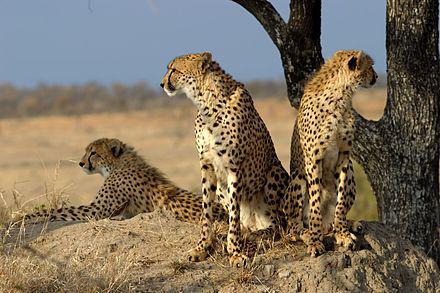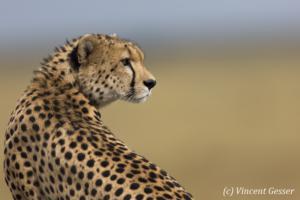The first image is the image on the left, the second image is the image on the right. Considering the images on both sides, is "The left image contains exactly three cheetahs, and the right image includes an adult cheetah with its back to the camera and its head turned sharply to gaze right." valid? Answer yes or no. Yes. The first image is the image on the left, the second image is the image on the right. Considering the images on both sides, is "The right image contains exactly one cheetah." valid? Answer yes or no. Yes. 